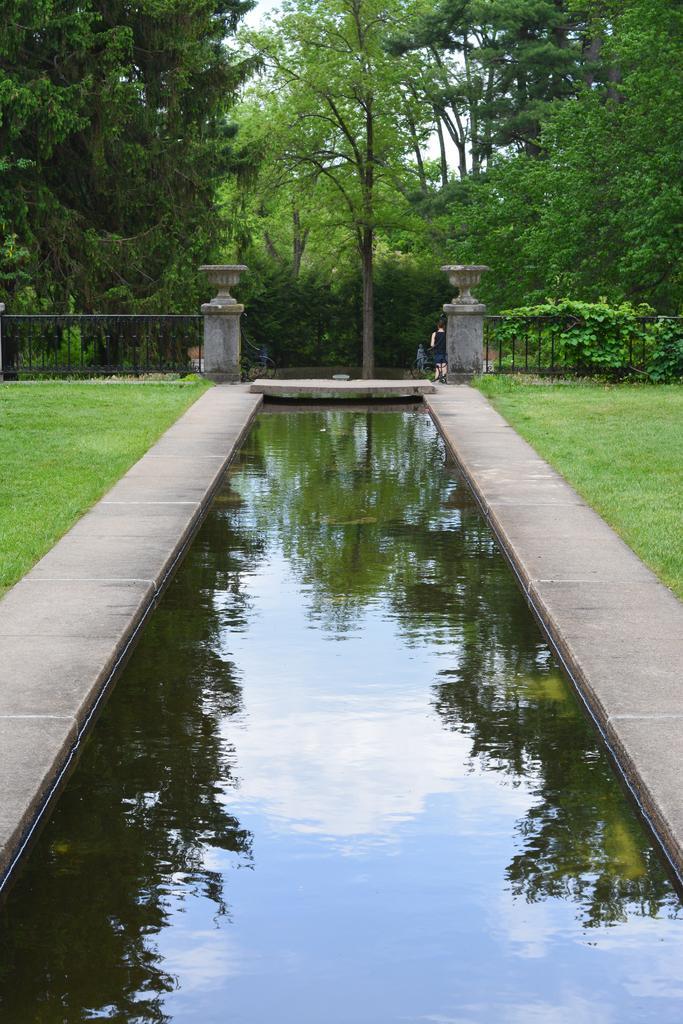Describe this image in one or two sentences. In this image in the front there is water and there's grass on the ground. In the center there is a fence and in the background there are trees. 